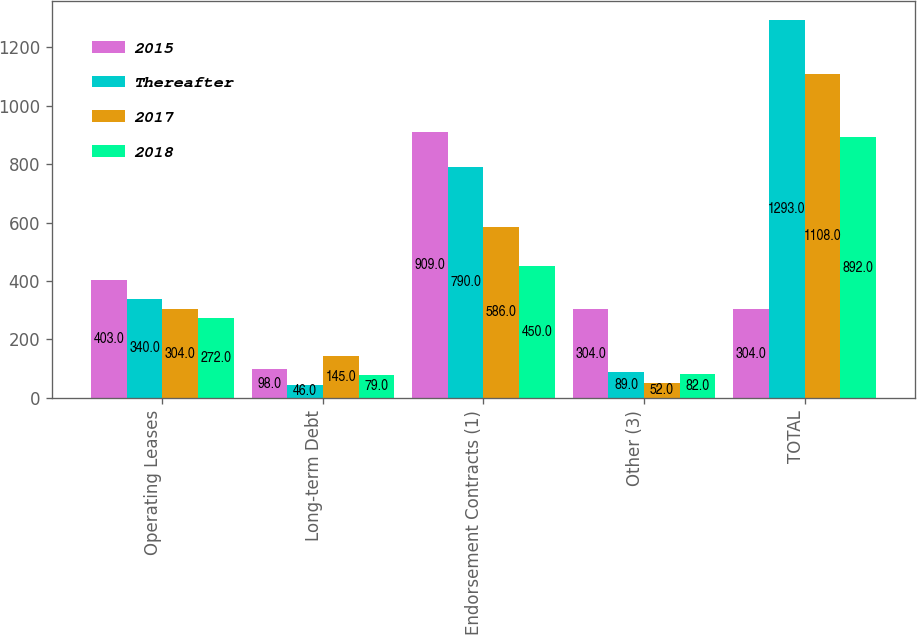Convert chart to OTSL. <chart><loc_0><loc_0><loc_500><loc_500><stacked_bar_chart><ecel><fcel>Operating Leases<fcel>Long-term Debt<fcel>Endorsement Contracts (1)<fcel>Other (3)<fcel>TOTAL<nl><fcel>2015<fcel>403<fcel>98<fcel>909<fcel>304<fcel>304<nl><fcel>Thereafter<fcel>340<fcel>46<fcel>790<fcel>89<fcel>1293<nl><fcel>2017<fcel>304<fcel>145<fcel>586<fcel>52<fcel>1108<nl><fcel>2018<fcel>272<fcel>79<fcel>450<fcel>82<fcel>892<nl></chart> 